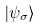<formula> <loc_0><loc_0><loc_500><loc_500>| \psi _ { \sigma } \rangle</formula> 